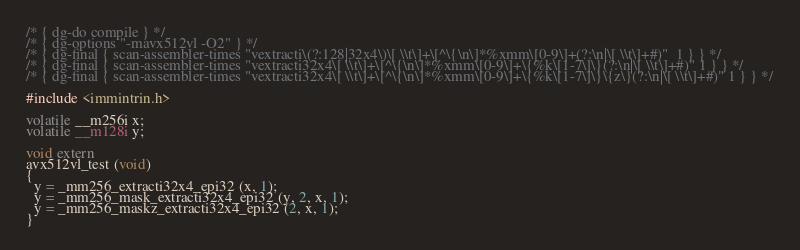Convert code to text. <code><loc_0><loc_0><loc_500><loc_500><_C_>/* { dg-do compile } */
/* { dg-options "-mavx512vl -O2" } */
/* { dg-final { scan-assembler-times "vextracti\(?:128|32x4\)\[ \\t\]+\[^\{\n\]*%xmm\[0-9\]+(?:\n|\[ \\t\]+#)"  1 } } */
/* { dg-final { scan-assembler-times "vextracti32x4\[ \\t\]+\[^\{\n\]*%xmm\[0-9\]+\{%k\[1-7\]\}(?:\n|\[ \\t\]+#)" 1 } } */
/* { dg-final { scan-assembler-times "vextracti32x4\[ \\t\]+\[^\{\n\]*%xmm\[0-9\]+\{%k\[1-7\]\}\{z\}(?:\n|\[ \\t\]+#)" 1 } } */

#include <immintrin.h>

volatile __m256i x;
volatile __m128i y;

void extern
avx512vl_test (void)
{
  y = _mm256_extracti32x4_epi32 (x, 1);
  y = _mm256_mask_extracti32x4_epi32 (y, 2, x, 1);
  y = _mm256_maskz_extracti32x4_epi32 (2, x, 1);
}
</code> 